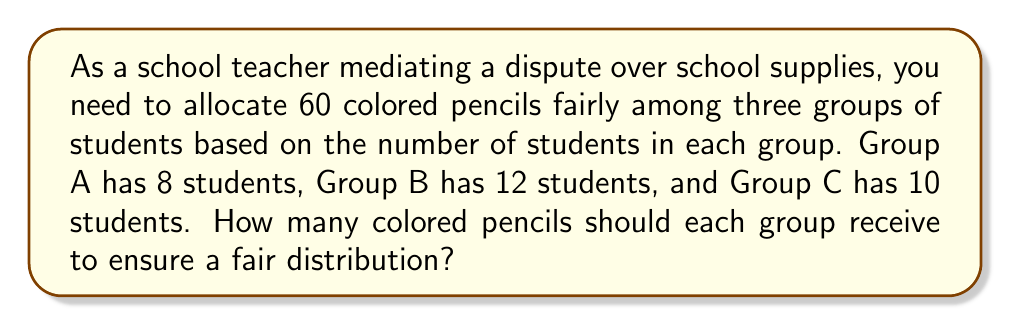Teach me how to tackle this problem. To allocate the colored pencils fairly, we need to use proportions. The number of pencils each group receives should be proportional to the number of students in that group.

1. First, let's calculate the total number of students:
   $8 + 12 + 10 = 30$ students in total

2. Now, we can set up proportions for each group:
   Group A: $\frac{8}{30} = \frac{x}{60}$
   Group B: $\frac{12}{30} = \frac{y}{60}$
   Group C: $\frac{10}{30} = \frac{z}{60}$

   Where $x$, $y$, and $z$ represent the number of pencils for each group.

3. Solve for $x$, $y$, and $z$:
   Group A: $x = \frac{8 \times 60}{30} = 16$ pencils
   Group B: $y = \frac{12 \times 60}{30} = 24$ pencils
   Group C: $z = \frac{10 \times 60}{30} = 20$ pencils

4. Verify that the total adds up to 60:
   $16 + 24 + 20 = 60$

This distribution ensures that each group receives a fair number of pencils proportional to their size.
Answer: Group A: 16 pencils
Group B: 24 pencils
Group C: 20 pencils 